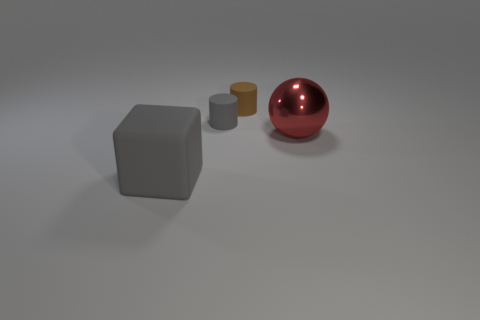Can you tell me something about the lighting in this image? The scene is lit diffusely with very soft shadows, indicating an environment with broad, even lighting. The lack of harsh shadows suggests the light source is either quite large or there's a method of diffusion in place, such as a lightbox or soft light in a studio setting. This gives the objects a gentle contrast and preserves their details. Is there more than one light source? Given the minimal environment and uniform shadows, it's difficult to determine the exact number of light sources without additional context. However, the softness of the shadows could imply the use of multiple lights to reduce the intensity of any single shadow, or a large singular source that evenly bathes the scene in light. 